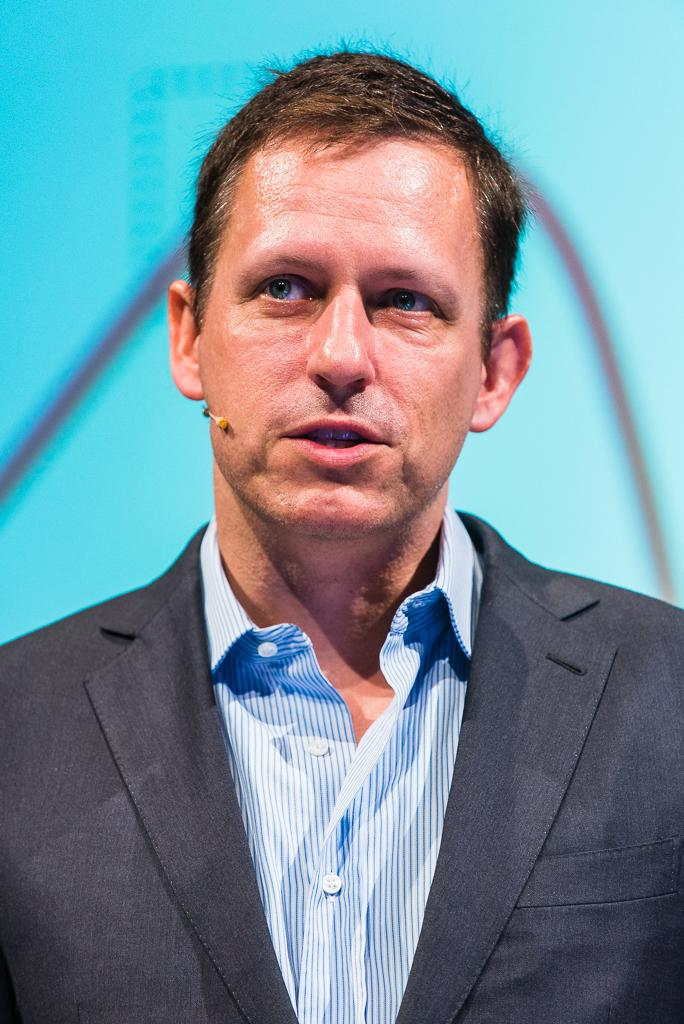Who is present in the image? There is a man in the image. What is the man wearing on his upper body? The man is wearing a white and blue color shirt and a coat. Can you describe the background of the image? The background of the image is blurred. How many beads are on the man's necklace in the image? There is no necklace or beads present in the image. What are the boys doing in the image? There are no boys present in the image; only a man is visible. 